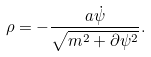Convert formula to latex. <formula><loc_0><loc_0><loc_500><loc_500>\rho = - \frac { a \dot { \psi } } { \sqrt { m ^ { 2 } + \partial \psi ^ { 2 } } } .</formula> 